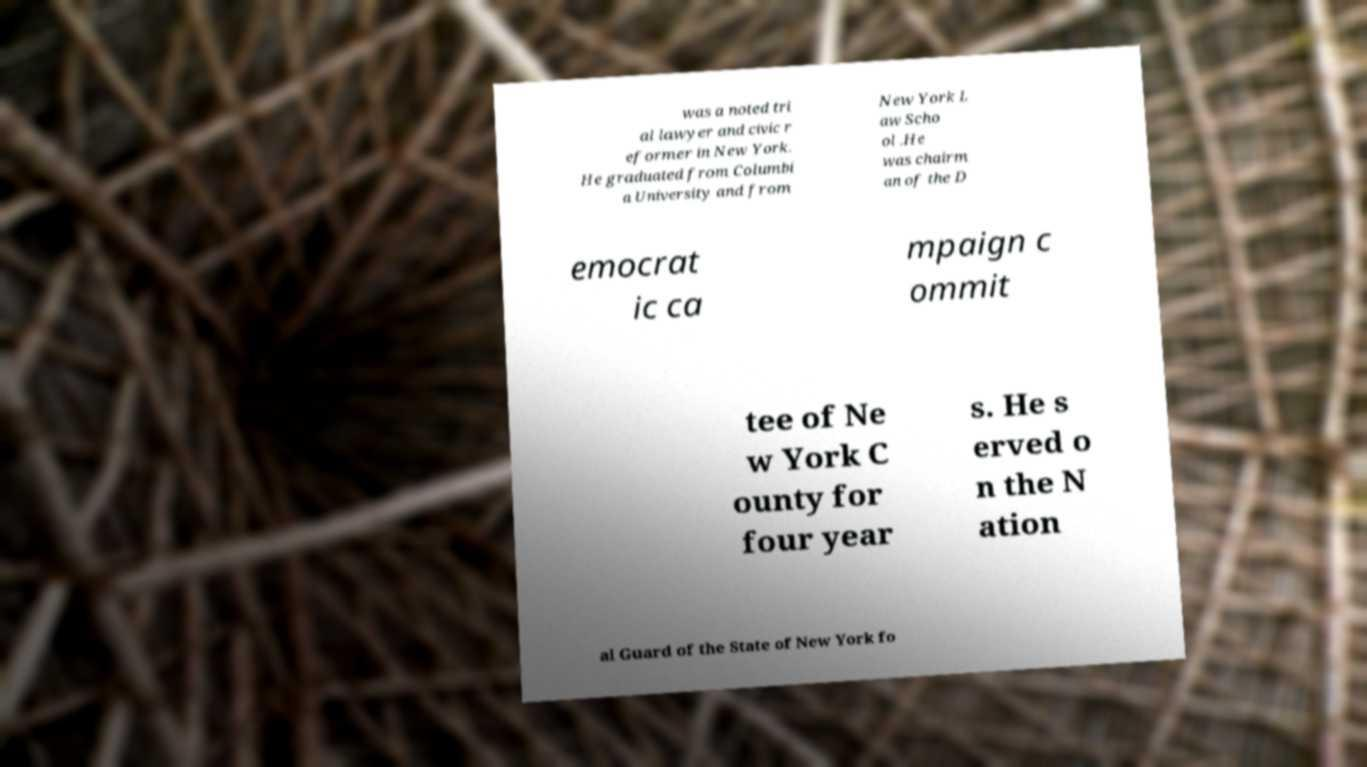Please identify and transcribe the text found in this image. was a noted tri al lawyer and civic r eformer in New York. He graduated from Columbi a University and from New York L aw Scho ol .He was chairm an of the D emocrat ic ca mpaign c ommit tee of Ne w York C ounty for four year s. He s erved o n the N ation al Guard of the State of New York fo 